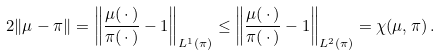Convert formula to latex. <formula><loc_0><loc_0><loc_500><loc_500>2 \| \mu - \pi \| = \left \| \frac { \mu ( \, \cdot \, ) } { \pi ( \, \cdot \, ) } - 1 \right \| _ { L ^ { 1 } ( \pi ) } \leq \left \| \frac { \mu ( \, \cdot \, ) } { \pi ( \, \cdot \, ) } - 1 \right \| _ { L ^ { 2 } ( \pi ) } = \chi ( \mu , \pi ) \, .</formula> 